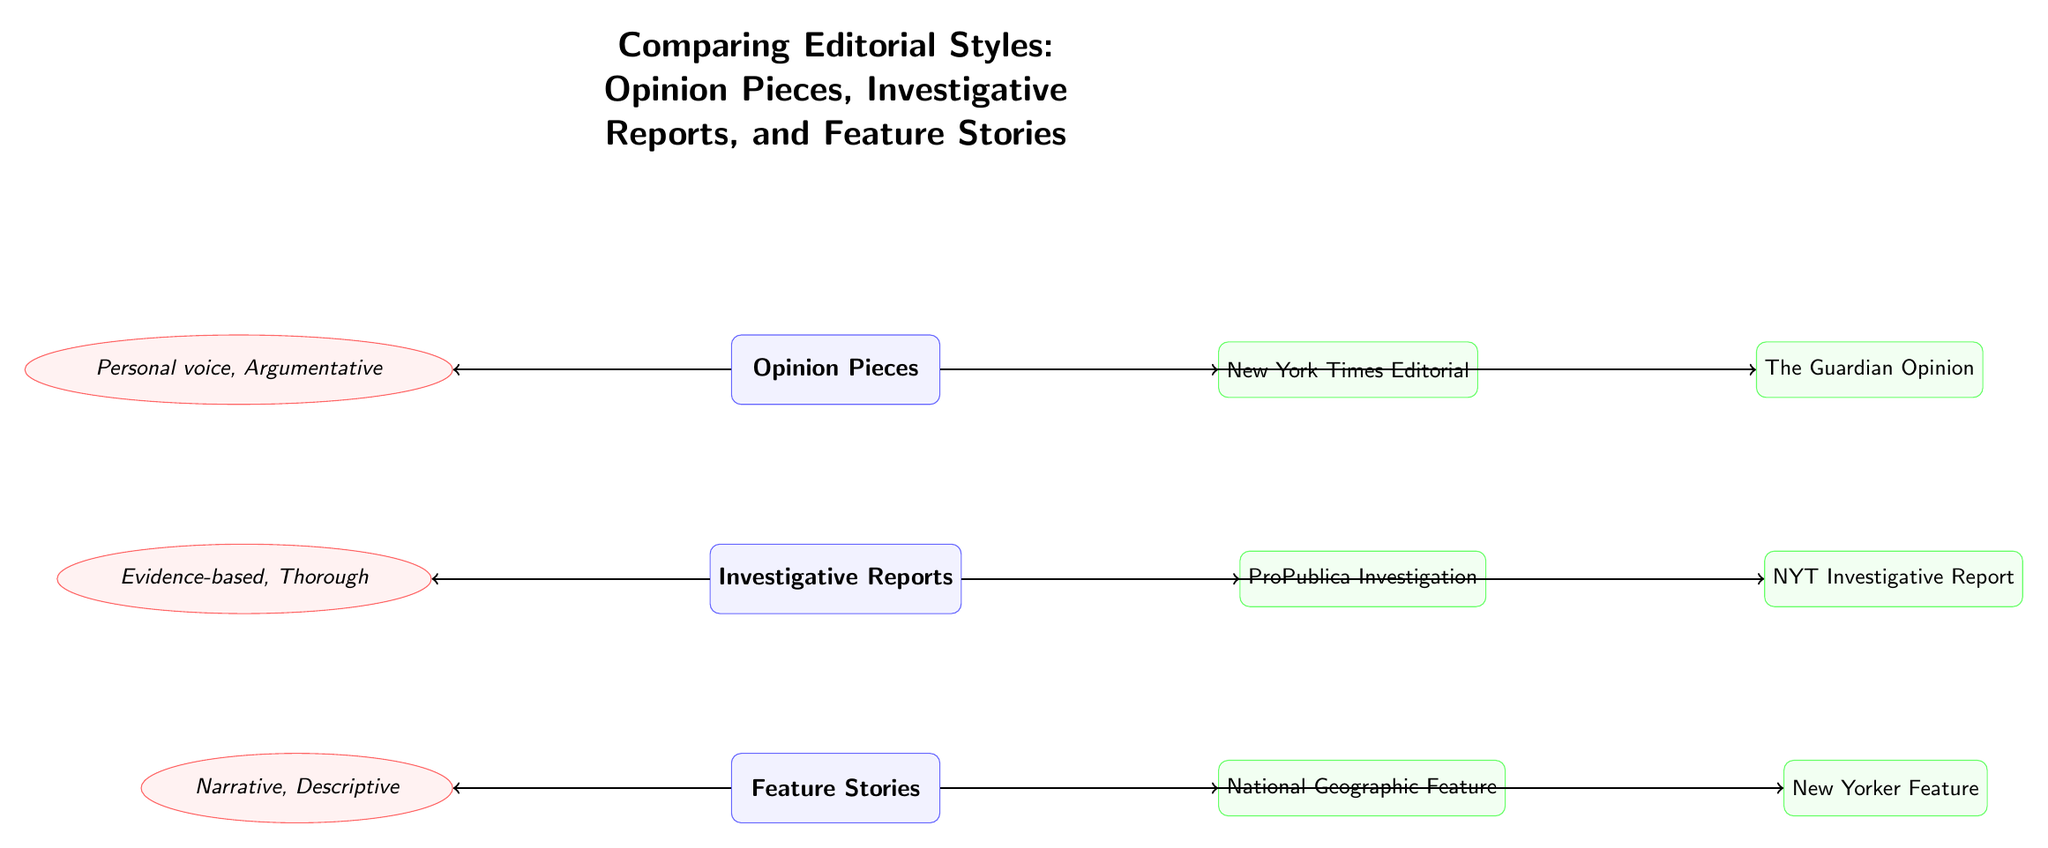What are the three types of editorials shown? The diagram lists three types: Opinion Pieces, Investigative Reports, and Feature Stories. Each type is represented as a category node.
Answer: Opinion Pieces, Investigative Reports, Feature Stories Which example is associated with Opinion Pieces? The diagram has two examples linked to Opinion Pieces: "New York Times Editorial" and "The Guardian Opinion," with arrows leading from the Opinion Pieces node to these examples.
Answer: New York Times Editorial, The Guardian Opinion What characteristic is described for Investigative Reports? The characteristic node associated with Investigative Reports states "Evidence-based, Thorough," and is connected by an arrow indicating its description of the editorial type.
Answer: Evidence-based, Thorough How many examples are provided for Feature Stories? There are two example nodes connected to Feature Stories: "National Geographic Feature" and "New Yorker Feature," which indicate the number of examples given.
Answer: 2 Which editorial type emphasizes a personal voice? The diagram shows that the characteristic for Opinion Pieces is "Personal voice, Argumentative," which indicates that this type emphasizes a personal voice distinctively.
Answer: Opinion Pieces What are the characteristics linked to Feature Stories? The characteristic associated with Feature Stories is "Narrative, Descriptive," which provides insight into the style and approach of this type of editorial through the connecting arrow.
Answer: Narrative, Descriptive Which example is linked to Investigative Reports? The examples connected to Investigative Reports in the diagram include "ProPublica Investigation" and "NYT Investigative Report," both of which are shown with arrows pointing from the Investigative Reports category.
Answer: ProPublica Investigation, NYT Investigative Report How does Opinion Pieces differ from Investigative Reports based on characteristics? Opinion Pieces have the characteristic "Personal voice, Argumentative," while Investigative Reports have "Evidence-based, Thorough," highlighting the different approaches in style and intent.
Answer: Personal voice, Argumentative; Evidence-based, Thorough 